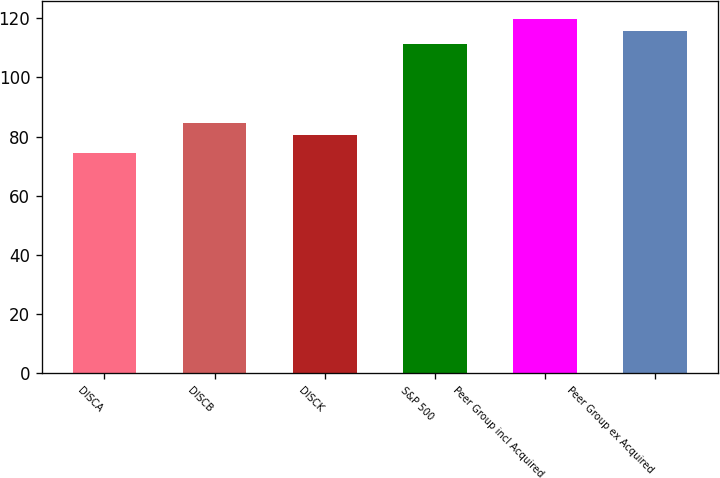<chart> <loc_0><loc_0><loc_500><loc_500><bar_chart><fcel>DISCA<fcel>DISCB<fcel>DISCK<fcel>S&P 500<fcel>Peer Group incl Acquired<fcel>Peer Group ex Acquired<nl><fcel>74.58<fcel>84.63<fcel>80.42<fcel>111.39<fcel>119.81<fcel>115.6<nl></chart> 